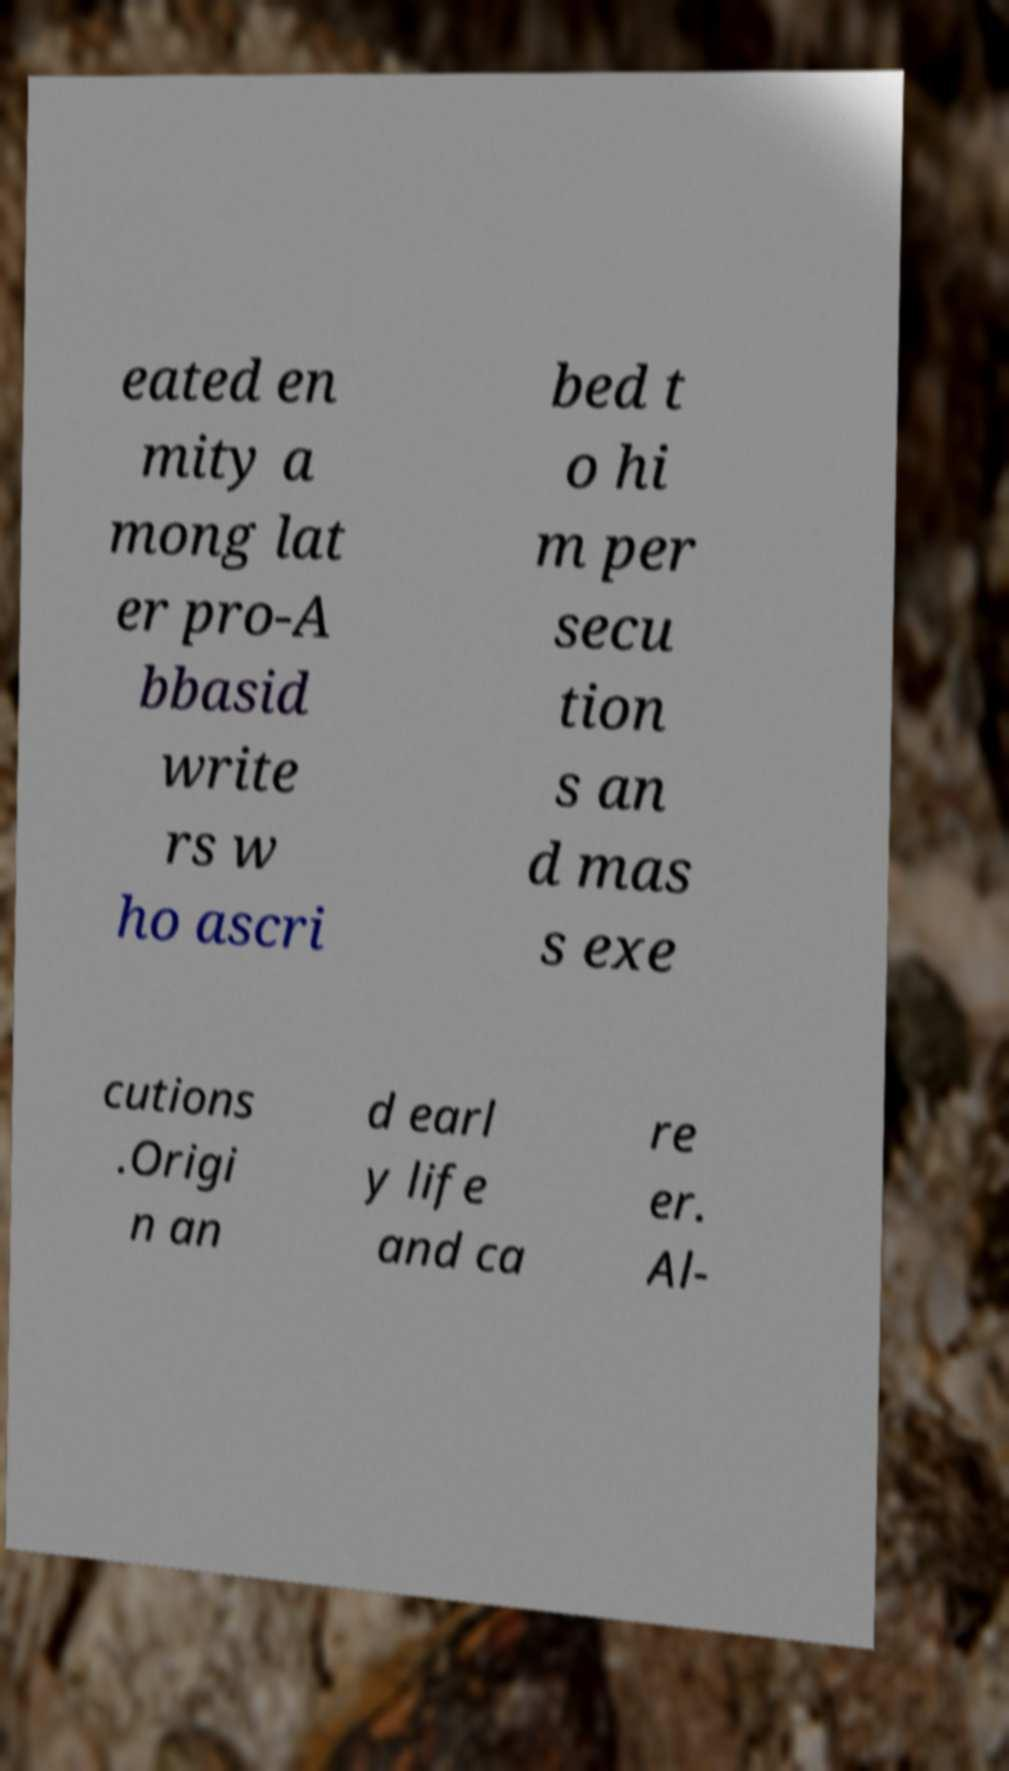Please read and relay the text visible in this image. What does it say? eated en mity a mong lat er pro-A bbasid write rs w ho ascri bed t o hi m per secu tion s an d mas s exe cutions .Origi n an d earl y life and ca re er. Al- 